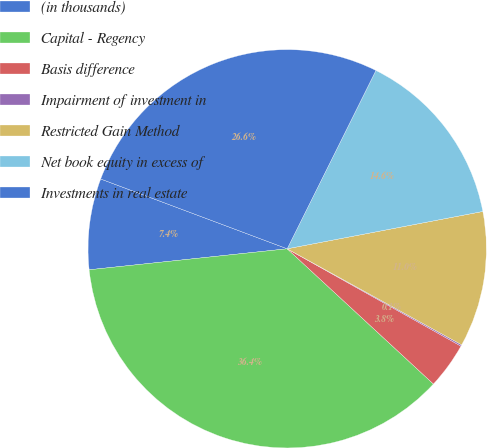Convert chart to OTSL. <chart><loc_0><loc_0><loc_500><loc_500><pie_chart><fcel>(in thousands)<fcel>Capital - Regency<fcel>Basis difference<fcel>Impairment of investment in<fcel>Restricted Gain Method<fcel>Net book equity in excess of<fcel>Investments in real estate<nl><fcel>7.38%<fcel>36.44%<fcel>3.75%<fcel>0.12%<fcel>11.01%<fcel>14.65%<fcel>26.65%<nl></chart> 